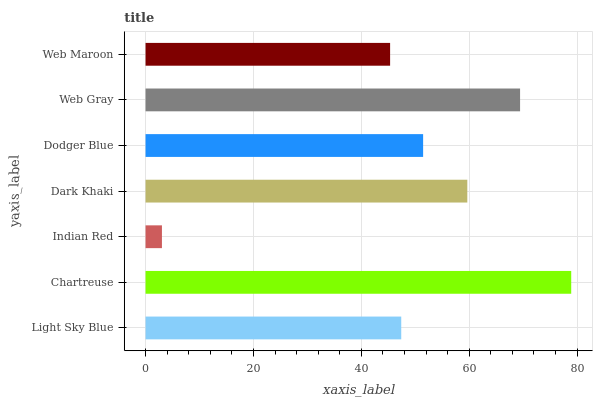Is Indian Red the minimum?
Answer yes or no. Yes. Is Chartreuse the maximum?
Answer yes or no. Yes. Is Chartreuse the minimum?
Answer yes or no. No. Is Indian Red the maximum?
Answer yes or no. No. Is Chartreuse greater than Indian Red?
Answer yes or no. Yes. Is Indian Red less than Chartreuse?
Answer yes or no. Yes. Is Indian Red greater than Chartreuse?
Answer yes or no. No. Is Chartreuse less than Indian Red?
Answer yes or no. No. Is Dodger Blue the high median?
Answer yes or no. Yes. Is Dodger Blue the low median?
Answer yes or no. Yes. Is Chartreuse the high median?
Answer yes or no. No. Is Chartreuse the low median?
Answer yes or no. No. 